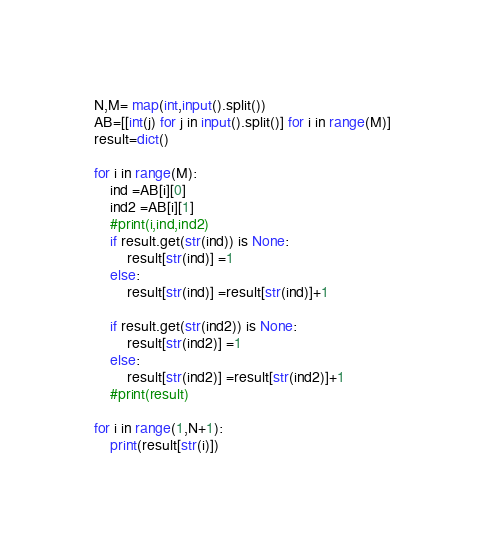<code> <loc_0><loc_0><loc_500><loc_500><_Python_>N,M= map(int,input().split())
AB=[[int(j) for j in input().split()] for i in range(M)]
result=dict()

for i in range(M):
    ind =AB[i][0]
    ind2 =AB[i][1]
    #print(i,ind,ind2)
    if result.get(str(ind)) is None:
        result[str(ind)] =1
    else:
        result[str(ind)] =result[str(ind)]+1
    
    if result.get(str(ind2)) is None:
        result[str(ind2)] =1
    else:
        result[str(ind2)] =result[str(ind2)]+1
    #print(result)
    
for i in range(1,N+1):    
    print(result[str(i)])</code> 